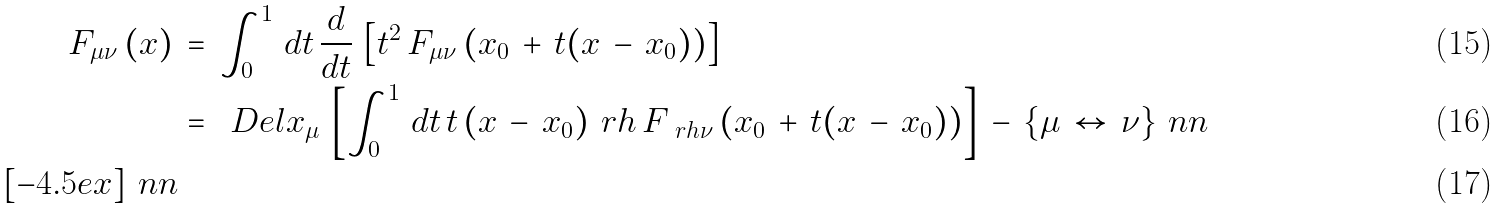<formula> <loc_0><loc_0><loc_500><loc_500>F _ { \mu \nu } \, ( x ) \, & = \, \int _ { 0 } ^ { 1 } \, d t \, \frac { d } { d t } \, \left [ t ^ { 2 } \, F _ { \mu \nu } \, ( x _ { 0 } \, + \, t ( x \, - \, x _ { 0 } ) ) \right ] \\ & = \, \ D e l { x } _ { \mu } \, \left [ \int _ { 0 } ^ { 1 } \, d t \, t \, ( x \, - \, x _ { 0 } ) ^ { \ } r h \, F _ { \ r h \nu } \, ( x _ { 0 } \, + \, t ( x \, - \, x _ { 0 } ) ) \right ] \, - \, \{ \mu \, \leftrightarrow \, \nu \} \ n n \\ [ - 4 . 5 e x ] \ n n</formula> 